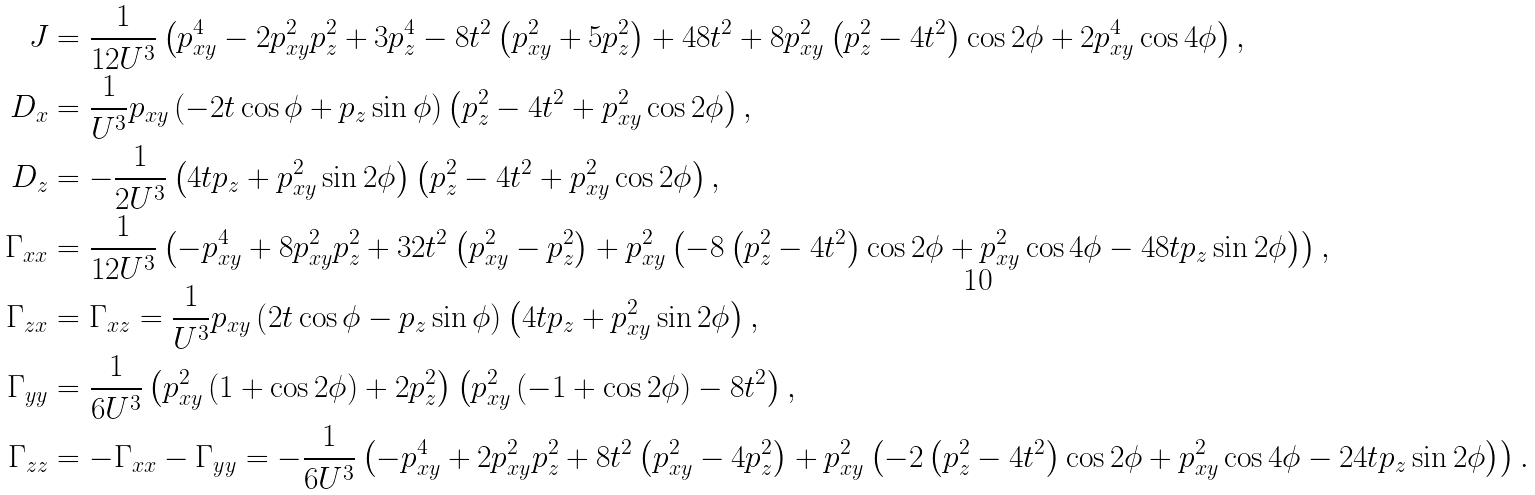Convert formula to latex. <formula><loc_0><loc_0><loc_500><loc_500>J & = \frac { 1 } { 1 2 U ^ { 3 } } \left ( p _ { x y } ^ { 4 } - 2 p _ { x y } ^ { 2 } p _ { z } ^ { 2 } + 3 p _ { z } ^ { 4 } - 8 t ^ { 2 } \left ( p _ { x y } ^ { 2 } + 5 p _ { z } ^ { 2 } \right ) + 4 8 t ^ { 2 } + 8 p _ { x y } ^ { 2 } \left ( p _ { z } ^ { 2 } - 4 t ^ { 2 } \right ) \cos { 2 \phi } + 2 p _ { x y } ^ { 4 } \cos { 4 \phi } \right ) , \\ D _ { x } & = \frac { 1 } { U ^ { 3 } } p _ { x y } \left ( - 2 t \cos { \phi } + p _ { z } \sin { \phi } \right ) \left ( p _ { z } ^ { 2 } - 4 t ^ { 2 } + p _ { x y } ^ { 2 } \cos { 2 \phi } \right ) , \\ D _ { z } & = - \frac { 1 } { 2 U ^ { 3 } } \left ( 4 t p _ { z } + p _ { x y } ^ { 2 } \sin { 2 \phi } \right ) \left ( p _ { z } ^ { 2 } - 4 t ^ { 2 } + p _ { x y } ^ { 2 } \cos { 2 \phi } \right ) , \\ \Gamma _ { x x } & = \frac { 1 } { 1 2 U ^ { 3 } } \left ( - p _ { x y } ^ { 4 } + 8 p _ { x y } ^ { 2 } p _ { z } ^ { 2 } + 3 2 t ^ { 2 } \left ( p _ { x y } ^ { 2 } - p _ { z } ^ { 2 } \right ) + p _ { x y } ^ { 2 } \left ( - 8 \left ( p _ { z } ^ { 2 } - 4 t ^ { 2 } \right ) \cos { 2 \phi } + p _ { x y } ^ { 2 } \cos { 4 \phi } - 4 8 t p _ { z } \sin { 2 \phi } \right ) \right ) , \\ \Gamma _ { z x } & = \Gamma _ { x z } = \frac { 1 } { U ^ { 3 } } p _ { x y } \left ( 2 t \cos { \phi } - p _ { z } \sin { \phi } \right ) \left ( 4 t p _ { z } + p _ { x y } ^ { 2 } \sin { 2 \phi } \right ) , \\ \Gamma _ { y y } & = \frac { 1 } { 6 U ^ { 3 } } \left ( p _ { x y } ^ { 2 } \left ( 1 + \cos { 2 \phi } \right ) + 2 p _ { z } ^ { 2 } \right ) \left ( p _ { x y } ^ { 2 } \left ( - 1 + \cos { 2 \phi } \right ) - 8 t ^ { 2 } \right ) , \\ \Gamma _ { z z } & = - \Gamma _ { x x } - \Gamma _ { y y } = - \frac { 1 } { 6 U ^ { 3 } } \left ( - p _ { x y } ^ { 4 } + 2 p _ { x y } ^ { 2 } p _ { z } ^ { 2 } + 8 t ^ { 2 } \left ( p _ { x y } ^ { 2 } - 4 p _ { z } ^ { 2 } \right ) + p _ { x y } ^ { 2 } \left ( - 2 \left ( p _ { z } ^ { 2 } - 4 t ^ { 2 } \right ) \cos { 2 \phi } + p _ { x y } ^ { 2 } \cos { 4 \phi } - 2 4 t p _ { z } \sin { 2 \phi } \right ) \right ) .</formula> 